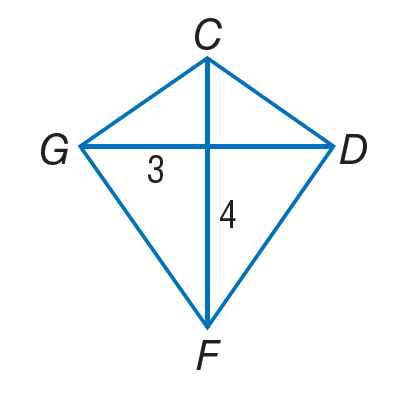Answer the mathemtical geometry problem and directly provide the correct option letter.
Question: If C D F G is a kite, find G F.
Choices: A: 3 B: 4 C: 5 D: 7 C 